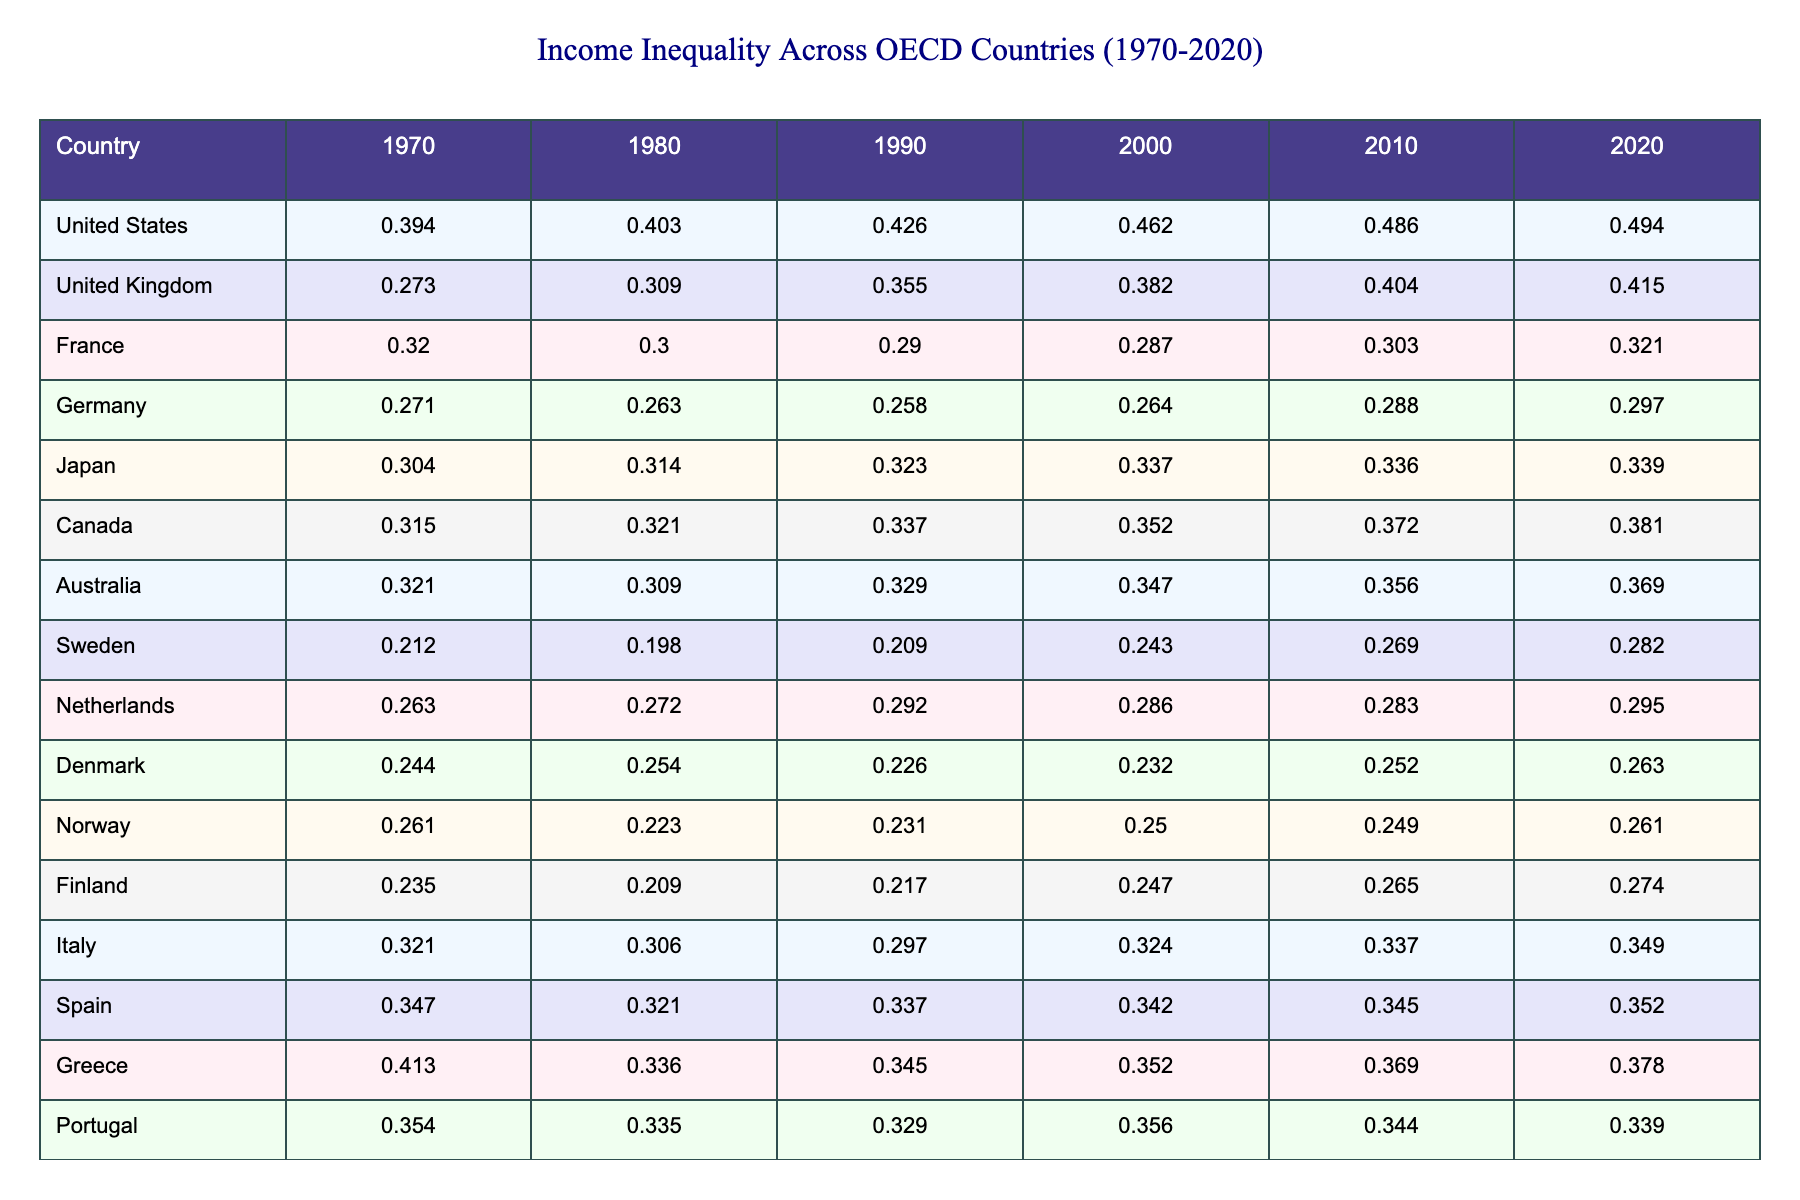What was the income inequality in the United States in 1990? The table indicates that the income inequality in the United States for the year 1990 is represented by the value 0.426.
Answer: 0.426 Which country had the lowest income inequality in 1970? By examining the 1970 column, Sweden shows the lowest income inequality value of 0.212 compared to the other countries listed.
Answer: Sweden What is the difference in income inequality between Japan in 1980 and Germany in 1980? The income inequality for Japan in 1980 is 0.314 and for Germany it is 0.263. The difference is calculated as 0.314 - 0.263 = 0.051.
Answer: 0.051 Which country had an increase in income inequality from 2000 to 2020? By comparing the values from 2000 to 2020, the United States (from 0.462 to 0.494) and Canada (from 0.352 to 0.381) both show an increase in income inequality during that period.
Answer: United States, Canada What was the average income inequality across all countries listed for the year 2010? To find the average, sum all the 2010 values: 0.486 (US) + 0.404 (UK) + 0.303 (France) + 0.288 (Germany) + 0.336 (Japan) + 0.372 (Canada) + 0.356 (Australia) + 0.269 (Sweden) + 0.283 (Netherlands) + 0.252 (Denmark) + 0.249 (Norway) + 0.265 (Finland) + 0.337 (Italy) + 0.345 (Spain) + 0.369 (Greece) + 0.344 (Portugal) + 0.313 (Ireland) + 0.282 (Belgium) + 0.283 (Austria) + 0.298 (Switzerland), which totals to approximately 5.315. Dividing this by the number of countries (20) gives an average of approximately 0.266.
Answer: 0.266 Did any country have a consistent decrease in income inequality from 1970 to 2020? By reviewing each country's values in the table, France is the only country that displays a decrease from 0.320 in 1970 to 0.321 in 2020, although it fluctuates with a peak in 1990. Thus, France did not have a consistent decrease, as the value increased again before slowly rising.
Answer: No Which country had the highest income inequality in 2020? The table shows that the United States has the highest income inequality value of 0.494 in 2020 compared to all listed countries.
Answer: United States What is the trend in income inequality for the Netherlands from 1970 to 2020? The values for the Netherlands are as follows: 0.263 (1970), 0.272 (1980), 0.292 (1990), 0.286 (2000), 0.283 (2010), and 0.295 (2020). This shows a generally increasing trend with only a slight drop in 2010.
Answer: Generally increasing Which two countries had the closest income inequality values in 2000? In 2000, the United Kingdom (0.382) and Germany (0.364) had the closest income inequality values, with a difference of only 0.018.
Answer: United Kingdom and Germany What percentage increase in income inequality did Greece experience from 1970 to 2020? Greece's income inequality increased from 0.413 in 1970 to 0.378 in 2020. The percentage increase is calculated as: ((0.378 - 0.413) / 0.413) * 100. This is a decrease of 8.47%. Thus, no increase occurred.
Answer: No increase 